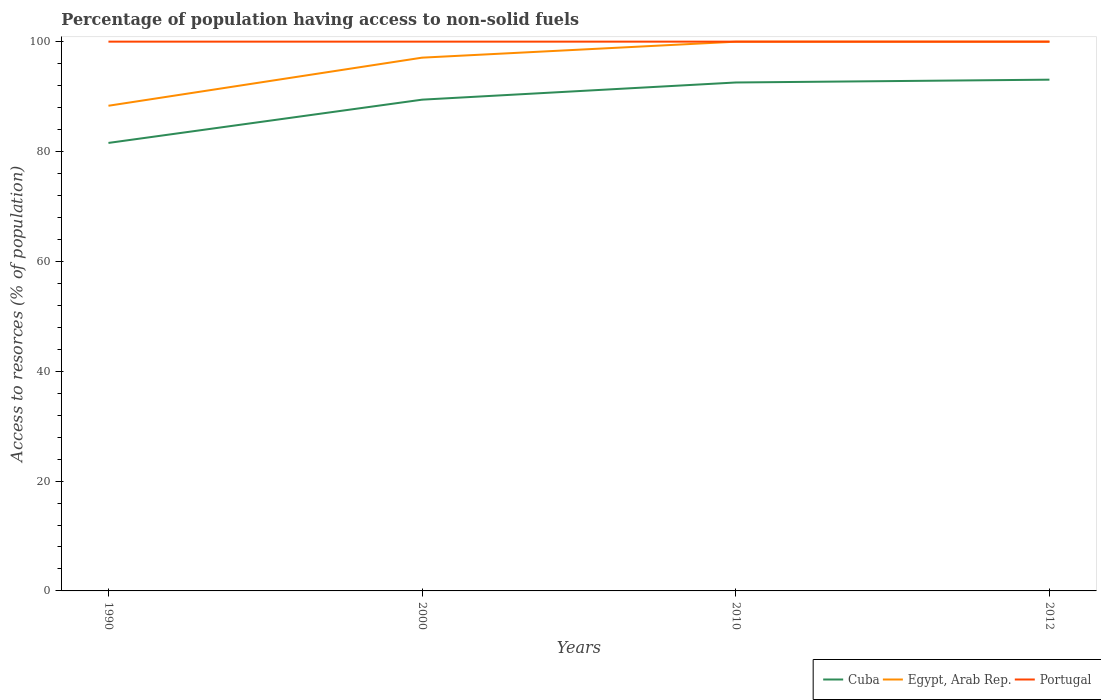How many different coloured lines are there?
Your answer should be compact. 3. Across all years, what is the maximum percentage of population having access to non-solid fuels in Portugal?
Offer a very short reply. 100. What is the total percentage of population having access to non-solid fuels in Portugal in the graph?
Make the answer very short. 0. Is the percentage of population having access to non-solid fuels in Egypt, Arab Rep. strictly greater than the percentage of population having access to non-solid fuels in Portugal over the years?
Give a very brief answer. Yes. What is the difference between two consecutive major ticks on the Y-axis?
Give a very brief answer. 20. Are the values on the major ticks of Y-axis written in scientific E-notation?
Keep it short and to the point. No. Does the graph contain grids?
Offer a very short reply. No. How many legend labels are there?
Your response must be concise. 3. How are the legend labels stacked?
Offer a terse response. Horizontal. What is the title of the graph?
Offer a terse response. Percentage of population having access to non-solid fuels. What is the label or title of the Y-axis?
Your answer should be compact. Access to resorces (% of population). What is the Access to resorces (% of population) in Cuba in 1990?
Your response must be concise. 81.56. What is the Access to resorces (% of population) of Egypt, Arab Rep. in 1990?
Make the answer very short. 88.33. What is the Access to resorces (% of population) in Portugal in 1990?
Ensure brevity in your answer.  100. What is the Access to resorces (% of population) in Cuba in 2000?
Make the answer very short. 89.44. What is the Access to resorces (% of population) of Egypt, Arab Rep. in 2000?
Offer a very short reply. 97.09. What is the Access to resorces (% of population) in Portugal in 2000?
Your answer should be very brief. 100. What is the Access to resorces (% of population) of Cuba in 2010?
Your answer should be compact. 92.56. What is the Access to resorces (% of population) in Egypt, Arab Rep. in 2010?
Make the answer very short. 99.99. What is the Access to resorces (% of population) of Portugal in 2010?
Your answer should be very brief. 100. What is the Access to resorces (% of population) of Cuba in 2012?
Give a very brief answer. 93.08. What is the Access to resorces (% of population) of Egypt, Arab Rep. in 2012?
Keep it short and to the point. 99.99. Across all years, what is the maximum Access to resorces (% of population) in Cuba?
Make the answer very short. 93.08. Across all years, what is the maximum Access to resorces (% of population) in Egypt, Arab Rep.?
Give a very brief answer. 99.99. Across all years, what is the maximum Access to resorces (% of population) in Portugal?
Give a very brief answer. 100. Across all years, what is the minimum Access to resorces (% of population) in Cuba?
Offer a terse response. 81.56. Across all years, what is the minimum Access to resorces (% of population) in Egypt, Arab Rep.?
Ensure brevity in your answer.  88.33. What is the total Access to resorces (% of population) of Cuba in the graph?
Ensure brevity in your answer.  356.64. What is the total Access to resorces (% of population) of Egypt, Arab Rep. in the graph?
Offer a very short reply. 385.39. What is the total Access to resorces (% of population) in Portugal in the graph?
Ensure brevity in your answer.  400. What is the difference between the Access to resorces (% of population) of Cuba in 1990 and that in 2000?
Offer a very short reply. -7.88. What is the difference between the Access to resorces (% of population) of Egypt, Arab Rep. in 1990 and that in 2000?
Offer a very short reply. -8.76. What is the difference between the Access to resorces (% of population) in Portugal in 1990 and that in 2000?
Offer a very short reply. 0. What is the difference between the Access to resorces (% of population) in Cuba in 1990 and that in 2010?
Your answer should be compact. -11. What is the difference between the Access to resorces (% of population) of Egypt, Arab Rep. in 1990 and that in 2010?
Keep it short and to the point. -11.66. What is the difference between the Access to resorces (% of population) of Cuba in 1990 and that in 2012?
Offer a terse response. -11.52. What is the difference between the Access to resorces (% of population) in Egypt, Arab Rep. in 1990 and that in 2012?
Provide a succinct answer. -11.66. What is the difference between the Access to resorces (% of population) of Cuba in 2000 and that in 2010?
Your answer should be compact. -3.13. What is the difference between the Access to resorces (% of population) of Egypt, Arab Rep. in 2000 and that in 2010?
Provide a short and direct response. -2.9. What is the difference between the Access to resorces (% of population) in Cuba in 2000 and that in 2012?
Your response must be concise. -3.64. What is the difference between the Access to resorces (% of population) of Egypt, Arab Rep. in 2000 and that in 2012?
Your answer should be very brief. -2.9. What is the difference between the Access to resorces (% of population) of Portugal in 2000 and that in 2012?
Provide a short and direct response. 0. What is the difference between the Access to resorces (% of population) in Cuba in 2010 and that in 2012?
Make the answer very short. -0.51. What is the difference between the Access to resorces (% of population) of Egypt, Arab Rep. in 2010 and that in 2012?
Offer a terse response. 0. What is the difference between the Access to resorces (% of population) of Portugal in 2010 and that in 2012?
Give a very brief answer. 0. What is the difference between the Access to resorces (% of population) in Cuba in 1990 and the Access to resorces (% of population) in Egypt, Arab Rep. in 2000?
Your answer should be compact. -15.52. What is the difference between the Access to resorces (% of population) of Cuba in 1990 and the Access to resorces (% of population) of Portugal in 2000?
Your answer should be compact. -18.44. What is the difference between the Access to resorces (% of population) of Egypt, Arab Rep. in 1990 and the Access to resorces (% of population) of Portugal in 2000?
Provide a succinct answer. -11.67. What is the difference between the Access to resorces (% of population) in Cuba in 1990 and the Access to resorces (% of population) in Egypt, Arab Rep. in 2010?
Offer a terse response. -18.43. What is the difference between the Access to resorces (% of population) in Cuba in 1990 and the Access to resorces (% of population) in Portugal in 2010?
Ensure brevity in your answer.  -18.44. What is the difference between the Access to resorces (% of population) in Egypt, Arab Rep. in 1990 and the Access to resorces (% of population) in Portugal in 2010?
Provide a succinct answer. -11.67. What is the difference between the Access to resorces (% of population) in Cuba in 1990 and the Access to resorces (% of population) in Egypt, Arab Rep. in 2012?
Provide a short and direct response. -18.43. What is the difference between the Access to resorces (% of population) in Cuba in 1990 and the Access to resorces (% of population) in Portugal in 2012?
Ensure brevity in your answer.  -18.44. What is the difference between the Access to resorces (% of population) in Egypt, Arab Rep. in 1990 and the Access to resorces (% of population) in Portugal in 2012?
Your answer should be compact. -11.67. What is the difference between the Access to resorces (% of population) of Cuba in 2000 and the Access to resorces (% of population) of Egypt, Arab Rep. in 2010?
Offer a very short reply. -10.55. What is the difference between the Access to resorces (% of population) in Cuba in 2000 and the Access to resorces (% of population) in Portugal in 2010?
Provide a succinct answer. -10.56. What is the difference between the Access to resorces (% of population) of Egypt, Arab Rep. in 2000 and the Access to resorces (% of population) of Portugal in 2010?
Make the answer very short. -2.92. What is the difference between the Access to resorces (% of population) in Cuba in 2000 and the Access to resorces (% of population) in Egypt, Arab Rep. in 2012?
Your answer should be compact. -10.55. What is the difference between the Access to resorces (% of population) in Cuba in 2000 and the Access to resorces (% of population) in Portugal in 2012?
Make the answer very short. -10.56. What is the difference between the Access to resorces (% of population) of Egypt, Arab Rep. in 2000 and the Access to resorces (% of population) of Portugal in 2012?
Provide a succinct answer. -2.92. What is the difference between the Access to resorces (% of population) in Cuba in 2010 and the Access to resorces (% of population) in Egypt, Arab Rep. in 2012?
Ensure brevity in your answer.  -7.43. What is the difference between the Access to resorces (% of population) in Cuba in 2010 and the Access to resorces (% of population) in Portugal in 2012?
Offer a terse response. -7.44. What is the difference between the Access to resorces (% of population) in Egypt, Arab Rep. in 2010 and the Access to resorces (% of population) in Portugal in 2012?
Give a very brief answer. -0.01. What is the average Access to resorces (% of population) in Cuba per year?
Provide a succinct answer. 89.16. What is the average Access to resorces (% of population) of Egypt, Arab Rep. per year?
Your answer should be very brief. 96.35. In the year 1990, what is the difference between the Access to resorces (% of population) in Cuba and Access to resorces (% of population) in Egypt, Arab Rep.?
Make the answer very short. -6.77. In the year 1990, what is the difference between the Access to resorces (% of population) in Cuba and Access to resorces (% of population) in Portugal?
Provide a short and direct response. -18.44. In the year 1990, what is the difference between the Access to resorces (% of population) of Egypt, Arab Rep. and Access to resorces (% of population) of Portugal?
Make the answer very short. -11.67. In the year 2000, what is the difference between the Access to resorces (% of population) of Cuba and Access to resorces (% of population) of Egypt, Arab Rep.?
Make the answer very short. -7.65. In the year 2000, what is the difference between the Access to resorces (% of population) in Cuba and Access to resorces (% of population) in Portugal?
Provide a short and direct response. -10.56. In the year 2000, what is the difference between the Access to resorces (% of population) of Egypt, Arab Rep. and Access to resorces (% of population) of Portugal?
Keep it short and to the point. -2.92. In the year 2010, what is the difference between the Access to resorces (% of population) in Cuba and Access to resorces (% of population) in Egypt, Arab Rep.?
Ensure brevity in your answer.  -7.43. In the year 2010, what is the difference between the Access to resorces (% of population) of Cuba and Access to resorces (% of population) of Portugal?
Keep it short and to the point. -7.44. In the year 2010, what is the difference between the Access to resorces (% of population) of Egypt, Arab Rep. and Access to resorces (% of population) of Portugal?
Your response must be concise. -0.01. In the year 2012, what is the difference between the Access to resorces (% of population) of Cuba and Access to resorces (% of population) of Egypt, Arab Rep.?
Your answer should be compact. -6.91. In the year 2012, what is the difference between the Access to resorces (% of population) of Cuba and Access to resorces (% of population) of Portugal?
Your answer should be compact. -6.92. In the year 2012, what is the difference between the Access to resorces (% of population) in Egypt, Arab Rep. and Access to resorces (% of population) in Portugal?
Give a very brief answer. -0.01. What is the ratio of the Access to resorces (% of population) of Cuba in 1990 to that in 2000?
Give a very brief answer. 0.91. What is the ratio of the Access to resorces (% of population) in Egypt, Arab Rep. in 1990 to that in 2000?
Your answer should be compact. 0.91. What is the ratio of the Access to resorces (% of population) of Portugal in 1990 to that in 2000?
Your answer should be very brief. 1. What is the ratio of the Access to resorces (% of population) of Cuba in 1990 to that in 2010?
Provide a short and direct response. 0.88. What is the ratio of the Access to resorces (% of population) of Egypt, Arab Rep. in 1990 to that in 2010?
Make the answer very short. 0.88. What is the ratio of the Access to resorces (% of population) of Cuba in 1990 to that in 2012?
Ensure brevity in your answer.  0.88. What is the ratio of the Access to resorces (% of population) in Egypt, Arab Rep. in 1990 to that in 2012?
Your answer should be very brief. 0.88. What is the ratio of the Access to resorces (% of population) in Portugal in 1990 to that in 2012?
Provide a short and direct response. 1. What is the ratio of the Access to resorces (% of population) in Cuba in 2000 to that in 2010?
Give a very brief answer. 0.97. What is the ratio of the Access to resorces (% of population) of Egypt, Arab Rep. in 2000 to that in 2010?
Provide a succinct answer. 0.97. What is the ratio of the Access to resorces (% of population) of Cuba in 2000 to that in 2012?
Your answer should be compact. 0.96. What is the ratio of the Access to resorces (% of population) of Egypt, Arab Rep. in 2000 to that in 2012?
Ensure brevity in your answer.  0.97. What is the ratio of the Access to resorces (% of population) in Portugal in 2010 to that in 2012?
Your answer should be very brief. 1. What is the difference between the highest and the second highest Access to resorces (% of population) of Cuba?
Keep it short and to the point. 0.51. What is the difference between the highest and the second highest Access to resorces (% of population) in Egypt, Arab Rep.?
Keep it short and to the point. 0. What is the difference between the highest and the lowest Access to resorces (% of population) in Cuba?
Provide a short and direct response. 11.52. What is the difference between the highest and the lowest Access to resorces (% of population) in Egypt, Arab Rep.?
Your answer should be compact. 11.66. 